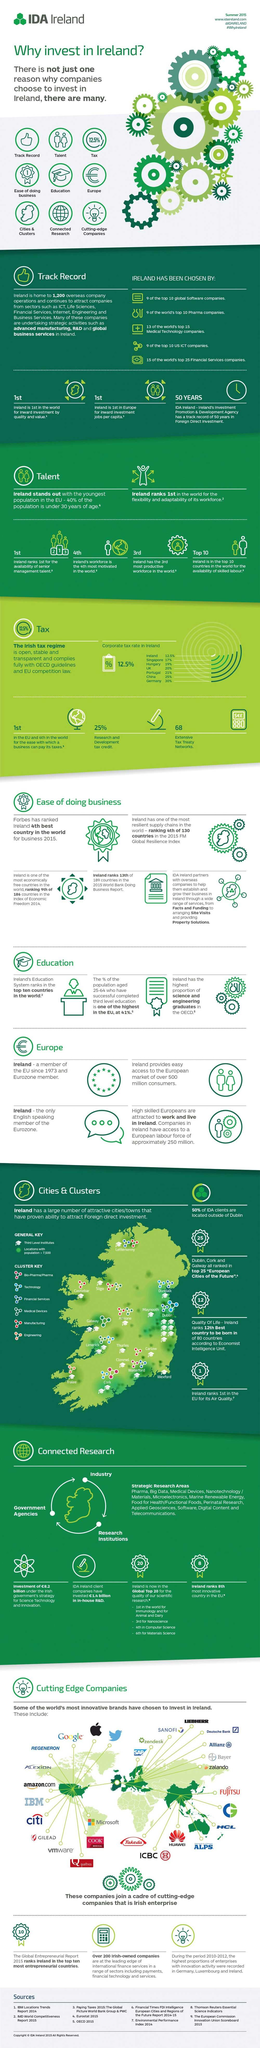Give some essential details in this illustration. In 2015, a total of 68 extensive tax treaty networks were established in Ireland. In 2015, approximately 41% of the population aged 25-64 years in Ireland had completed third-level education. The research and development tax credit in Ireland in 2015 was 25%. The corporate tax rate in the UK was 20% in 2015. 